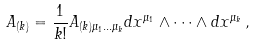<formula> <loc_0><loc_0><loc_500><loc_500>A _ { ( k ) } = { \frac { 1 } { k ! } } A _ { ( k ) \mu _ { 1 } \dots \mu _ { k } } d x ^ { \mu _ { 1 } } \wedge \dots \wedge d x ^ { \mu _ { k } } \, ,</formula> 